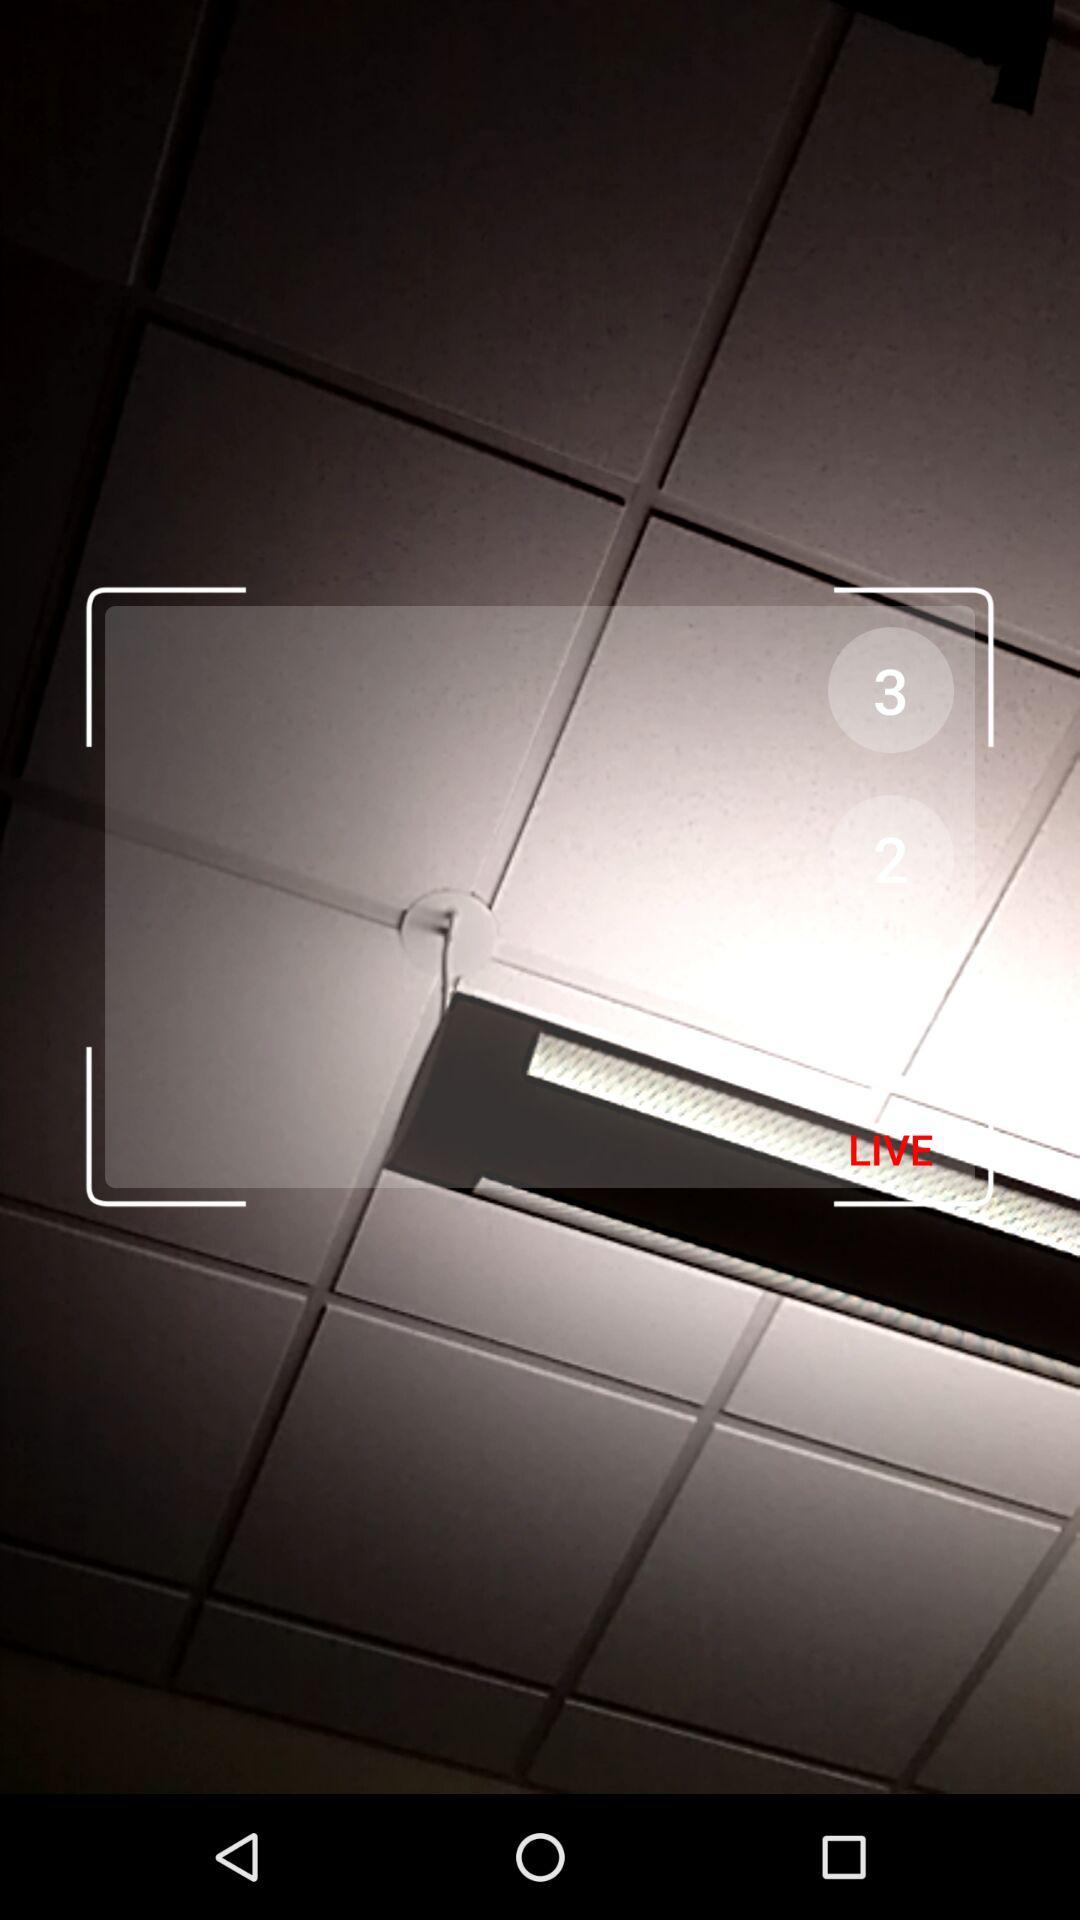How many numbers are greater than 2 on the screen?
Answer the question using a single word or phrase. 1 